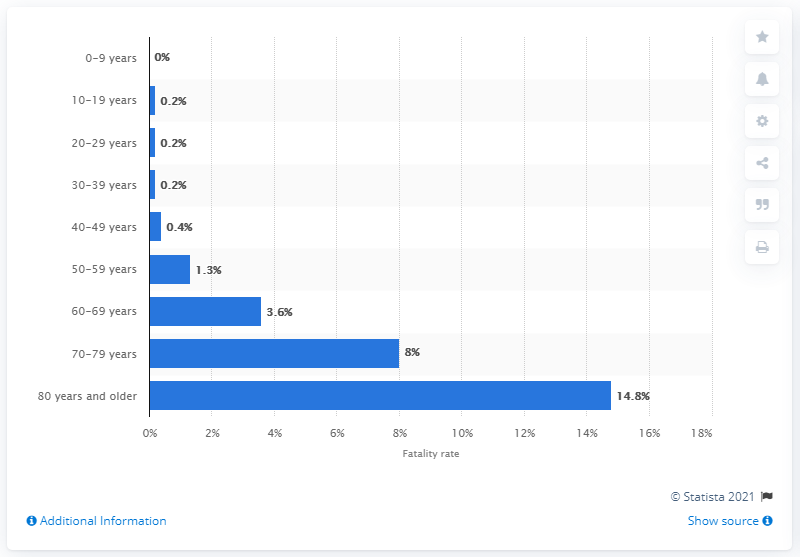Outline some significant characteristics in this image. As of February 11, 2020, the fatality rate of patients aged 80 and older was 14.8%. 